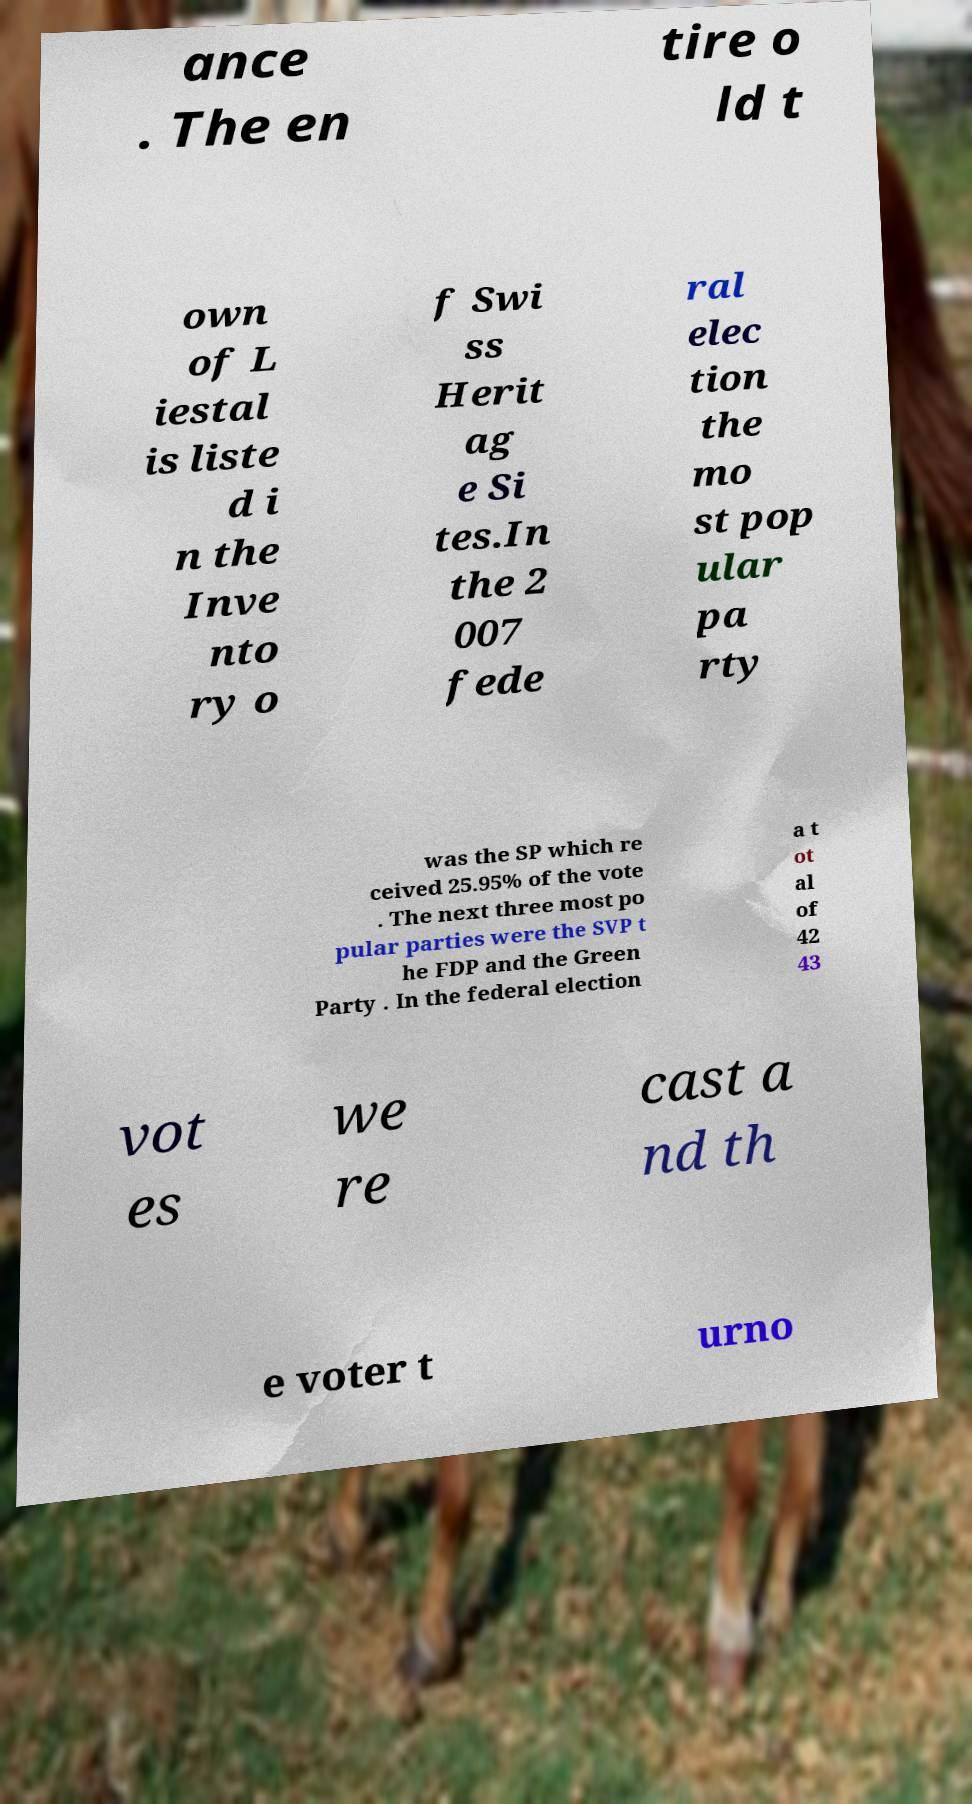What messages or text are displayed in this image? I need them in a readable, typed format. ance . The en tire o ld t own of L iestal is liste d i n the Inve nto ry o f Swi ss Herit ag e Si tes.In the 2 007 fede ral elec tion the mo st pop ular pa rty was the SP which re ceived 25.95% of the vote . The next three most po pular parties were the SVP t he FDP and the Green Party . In the federal election a t ot al of 42 43 vot es we re cast a nd th e voter t urno 